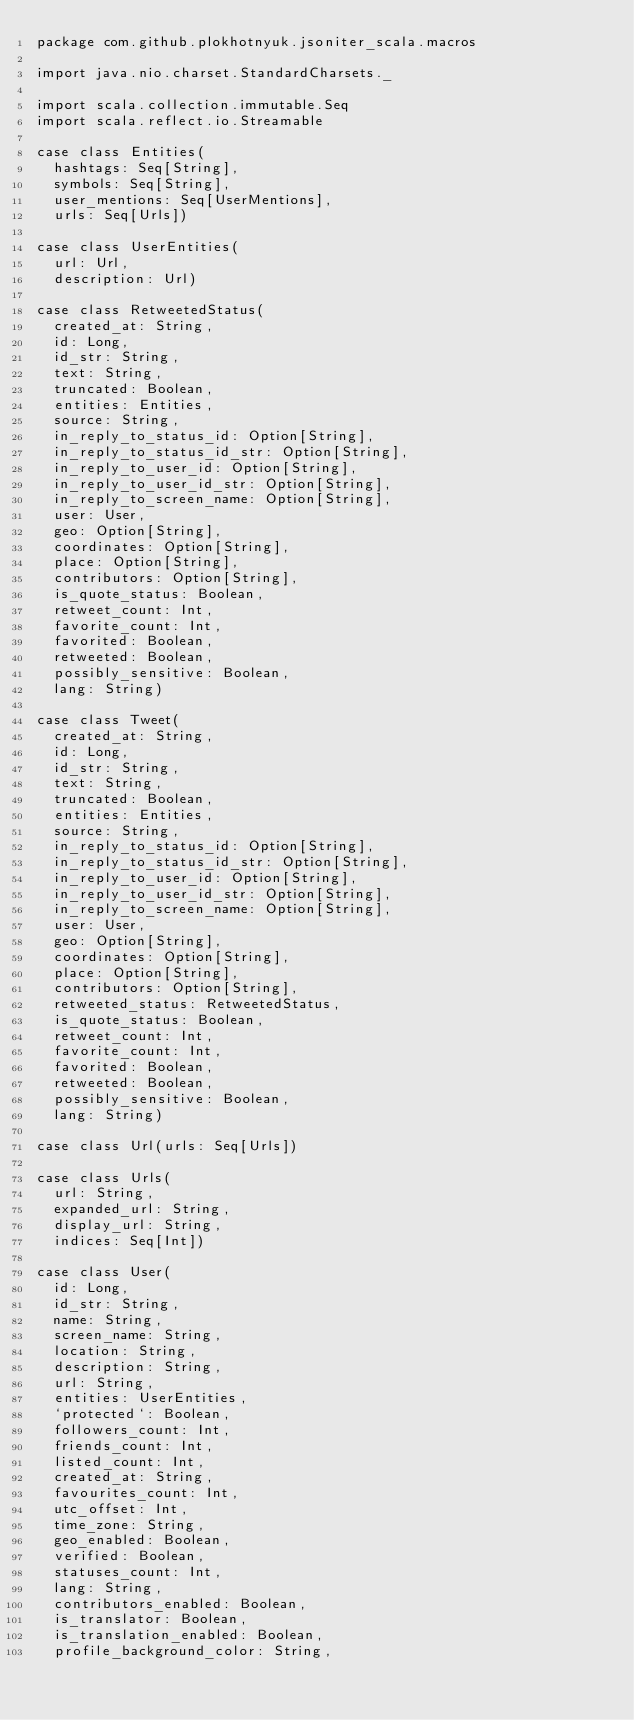Convert code to text. <code><loc_0><loc_0><loc_500><loc_500><_Scala_>package com.github.plokhotnyuk.jsoniter_scala.macros

import java.nio.charset.StandardCharsets._

import scala.collection.immutable.Seq
import scala.reflect.io.Streamable

case class Entities(
  hashtags: Seq[String],
  symbols: Seq[String],
  user_mentions: Seq[UserMentions],
  urls: Seq[Urls])

case class UserEntities(
  url: Url,
  description: Url)

case class RetweetedStatus(
  created_at: String,
  id: Long,
  id_str: String,
  text: String,
  truncated: Boolean,
  entities: Entities,
  source: String,
  in_reply_to_status_id: Option[String],
  in_reply_to_status_id_str: Option[String],
  in_reply_to_user_id: Option[String],
  in_reply_to_user_id_str: Option[String],
  in_reply_to_screen_name: Option[String],
  user: User,
  geo: Option[String],
  coordinates: Option[String],
  place: Option[String],
  contributors: Option[String],
  is_quote_status: Boolean,
  retweet_count: Int,
  favorite_count: Int,
  favorited: Boolean,
  retweeted: Boolean,
  possibly_sensitive: Boolean,
  lang: String)

case class Tweet(
  created_at: String,
  id: Long,
  id_str: String,
  text: String,
  truncated: Boolean,
  entities: Entities,
  source: String,
  in_reply_to_status_id: Option[String],
  in_reply_to_status_id_str: Option[String],
  in_reply_to_user_id: Option[String],
  in_reply_to_user_id_str: Option[String],
  in_reply_to_screen_name: Option[String],
  user: User,
  geo: Option[String],
  coordinates: Option[String],
  place: Option[String],
  contributors: Option[String],
  retweeted_status: RetweetedStatus,
  is_quote_status: Boolean,
  retweet_count: Int,
  favorite_count: Int,
  favorited: Boolean,
  retweeted: Boolean,
  possibly_sensitive: Boolean,
  lang: String)

case class Url(urls: Seq[Urls])

case class Urls(
  url: String,
  expanded_url: String,
  display_url: String,
  indices: Seq[Int])

case class User(
  id: Long,
  id_str: String,
  name: String,
  screen_name: String,
  location: String,
  description: String,
  url: String,
  entities: UserEntities,
  `protected`: Boolean,
  followers_count: Int,
  friends_count: Int,
  listed_count: Int,
  created_at: String,
  favourites_count: Int,
  utc_offset: Int,
  time_zone: String,
  geo_enabled: Boolean,
  verified: Boolean,
  statuses_count: Int,
  lang: String,
  contributors_enabled: Boolean,
  is_translator: Boolean,
  is_translation_enabled: Boolean,
  profile_background_color: String,</code> 